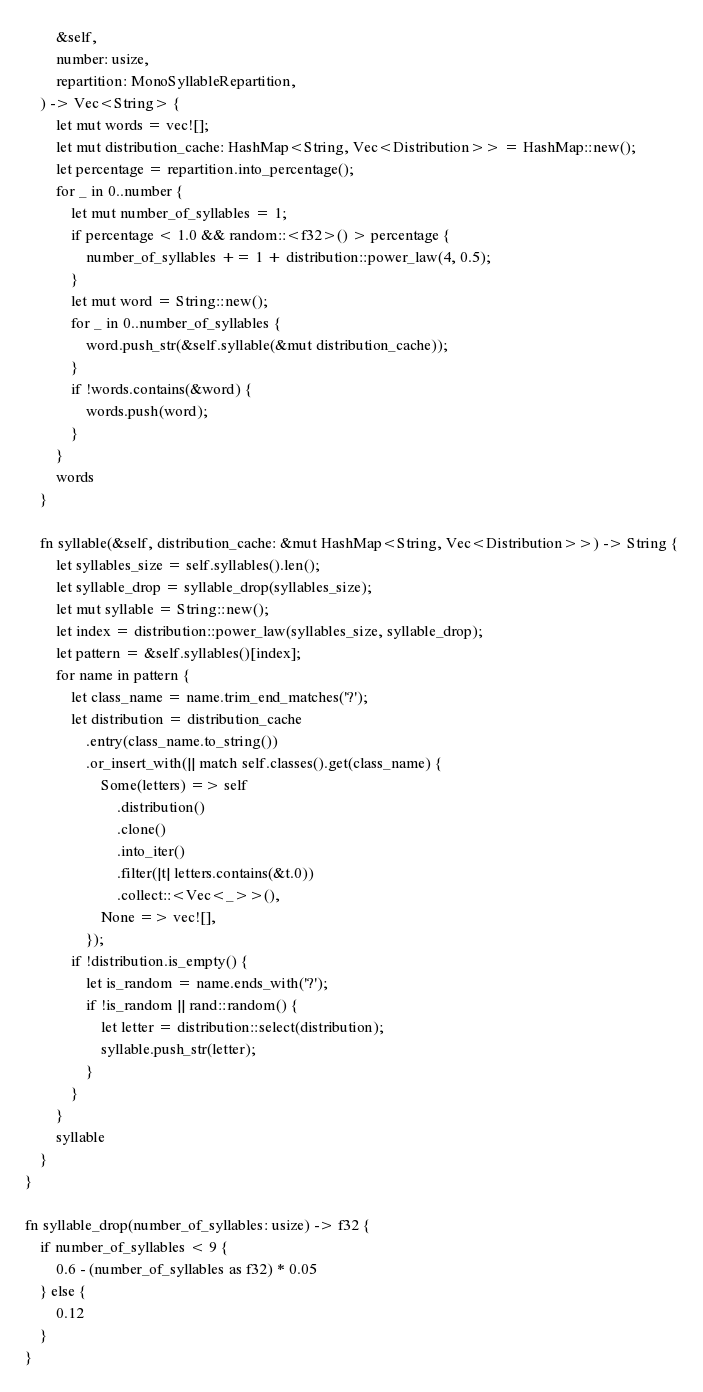<code> <loc_0><loc_0><loc_500><loc_500><_Rust_>        &self,
        number: usize,
        repartition: MonoSyllableRepartition,
    ) -> Vec<String> {
        let mut words = vec![];
        let mut distribution_cache: HashMap<String, Vec<Distribution>> = HashMap::new();
        let percentage = repartition.into_percentage();
        for _ in 0..number {
            let mut number_of_syllables = 1;
            if percentage < 1.0 && random::<f32>() > percentage {
                number_of_syllables += 1 + distribution::power_law(4, 0.5);
            }
            let mut word = String::new();
            for _ in 0..number_of_syllables {
                word.push_str(&self.syllable(&mut distribution_cache));
            }
            if !words.contains(&word) {
                words.push(word);
            }
        }
        words
    }

    fn syllable(&self, distribution_cache: &mut HashMap<String, Vec<Distribution>>) -> String {
        let syllables_size = self.syllables().len();
        let syllable_drop = syllable_drop(syllables_size);
        let mut syllable = String::new();
        let index = distribution::power_law(syllables_size, syllable_drop);
        let pattern = &self.syllables()[index];
        for name in pattern {
            let class_name = name.trim_end_matches('?');
            let distribution = distribution_cache
                .entry(class_name.to_string())
                .or_insert_with(|| match self.classes().get(class_name) {
                    Some(letters) => self
                        .distribution()
                        .clone()
                        .into_iter()
                        .filter(|t| letters.contains(&t.0))
                        .collect::<Vec<_>>(),
                    None => vec![],
                });
            if !distribution.is_empty() {
                let is_random = name.ends_with('?');
                if !is_random || rand::random() {
                    let letter = distribution::select(distribution);
                    syllable.push_str(letter);
                }
            }
        }
        syllable
    }
}

fn syllable_drop(number_of_syllables: usize) -> f32 {
    if number_of_syllables < 9 {
        0.6 - (number_of_syllables as f32) * 0.05
    } else {
        0.12
    }
}
</code> 